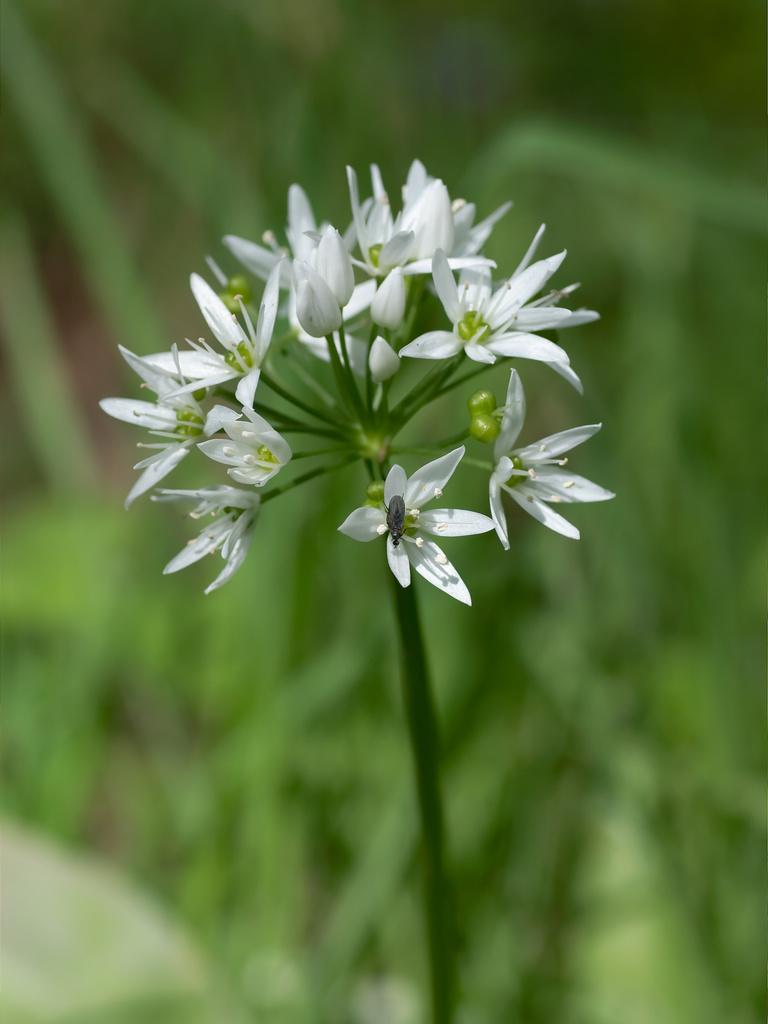Please provide a concise description of this image. In this image there is a plant to which there are so many small white color flowers and some buds. In the background there are plants with green leaves. 